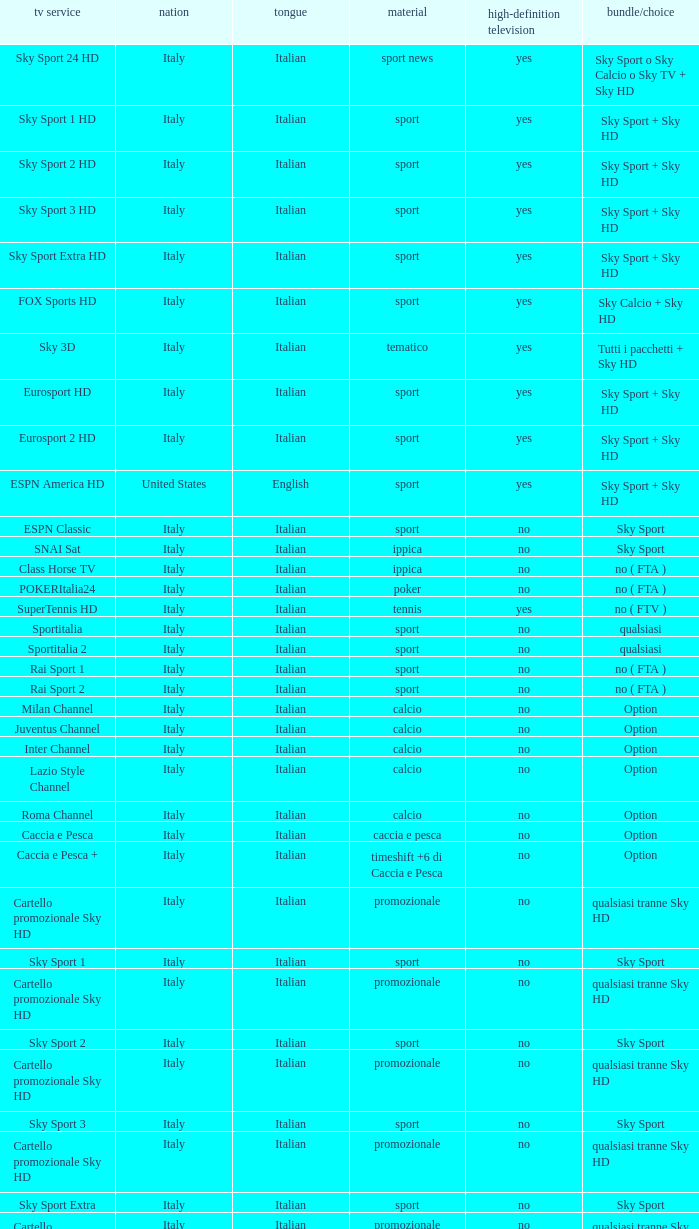What is Package/Option, when Content is Tennis? No ( ftv ). 